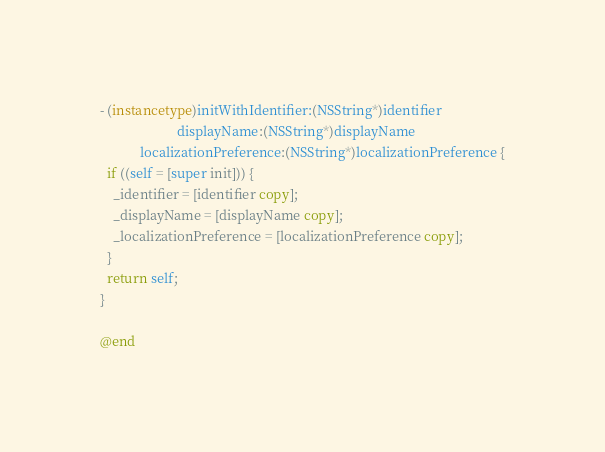<code> <loc_0><loc_0><loc_500><loc_500><_ObjectiveC_>- (instancetype)initWithIdentifier:(NSString*)identifier
                       displayName:(NSString*)displayName
            localizationPreference:(NSString*)localizationPreference {
  if ((self = [super init])) {
    _identifier = [identifier copy];
    _displayName = [displayName copy];
    _localizationPreference = [localizationPreference copy];
  }
  return self;
}

@end
</code> 